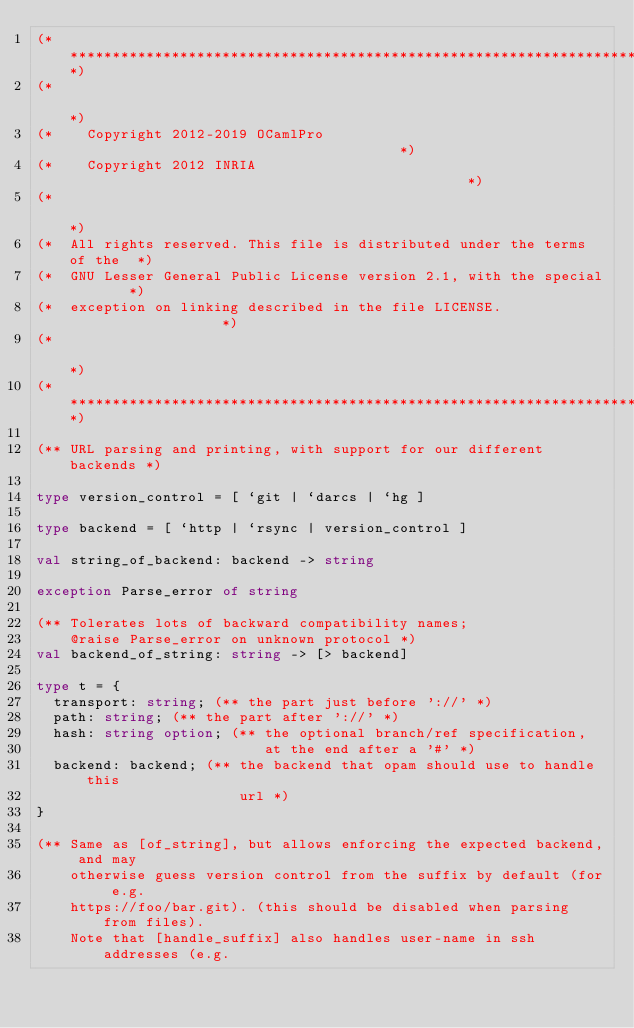<code> <loc_0><loc_0><loc_500><loc_500><_OCaml_>(**************************************************************************)
(*                                                                        *)
(*    Copyright 2012-2019 OCamlPro                                        *)
(*    Copyright 2012 INRIA                                                *)
(*                                                                        *)
(*  All rights reserved. This file is distributed under the terms of the  *)
(*  GNU Lesser General Public License version 2.1, with the special       *)
(*  exception on linking described in the file LICENSE.                   *)
(*                                                                        *)
(**************************************************************************)

(** URL parsing and printing, with support for our different backends *)

type version_control = [ `git | `darcs | `hg ]

type backend = [ `http | `rsync | version_control ]

val string_of_backend: backend -> string

exception Parse_error of string

(** Tolerates lots of backward compatibility names;
    @raise Parse_error on unknown protocol *)
val backend_of_string: string -> [> backend]

type t = {
  transport: string; (** the part just before '://' *)
  path: string; (** the part after '://' *)
  hash: string option; (** the optional branch/ref specification,
                           at the end after a '#' *)
  backend: backend; (** the backend that opam should use to handle this
                        url *)
}

(** Same as [of_string], but allows enforcing the expected backend, and may
    otherwise guess version control from the suffix by default (for e.g.
    https://foo/bar.git). (this should be disabled when parsing from files).
    Note that [handle_suffix] also handles user-name in ssh addresses (e.g.</code> 